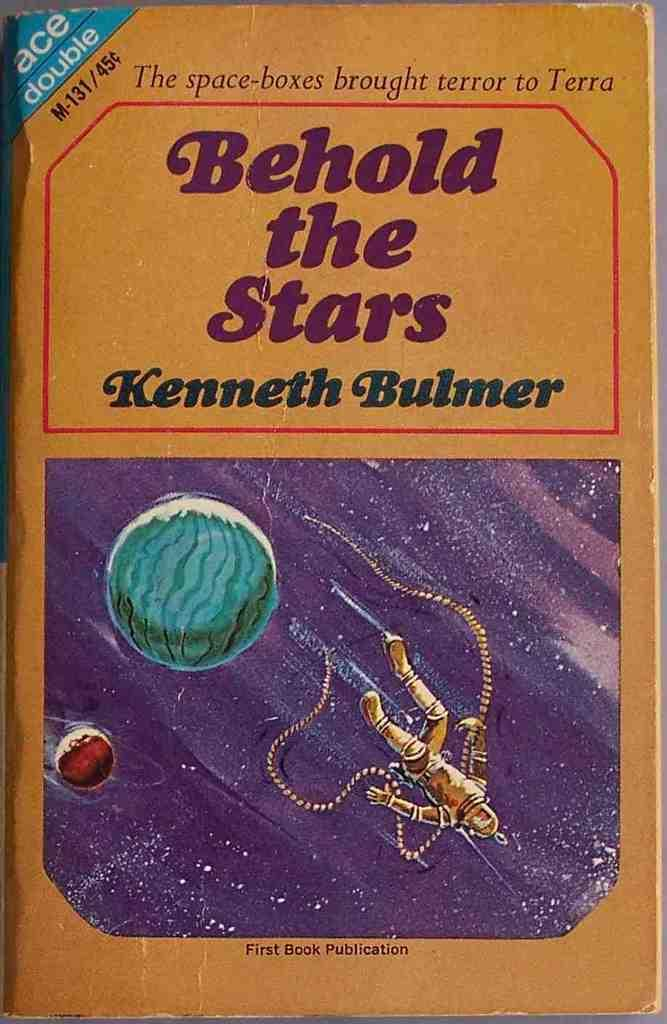<image>
Summarize the visual content of the image. A book called Behold The Stars has an astronaut on the cover. 